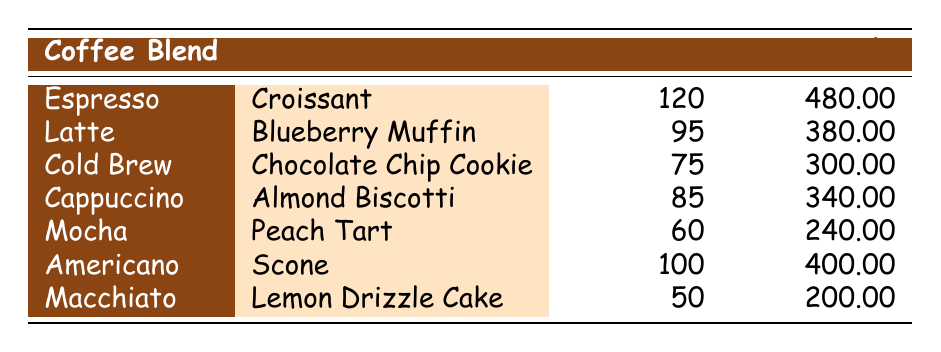What was the best-selling coffee blend in October 2023? The best-selling coffee blend can be found by looking at the "Units Sold" column. Among all the coffee blends, Espresso has the highest units sold at 120.
Answer: Espresso Which pastry was paired with the Mocha coffee blend? The table indicates the pairing for each coffee blend; for Mocha, the paired pastry is Peach Tart.
Answer: Peach Tart How much revenue did the Americano generate in October 2023? The revenue for the Americano coffee blend can be found directly in the "Revenue" column. For Americano, the revenue is $400.00.
Answer: 400.00 What was the total revenue generated from all coffee blends in October 2023? To find the total revenue, I will sum the revenue values for each coffee blend: 480 + 380 + 300 + 340 + 240 + 400 + 200 = 2320.00.
Answer: 2320.00 Did the Cappuccino sell more units than the Cold Brew? Looking at the "Units Sold" column, Cappuccino has 85 units sold while Cold Brew has 75 units sold. Thus, Cappuccino sold more units.
Answer: Yes What is the average number of units sold across all coffee blends? I will calculate this by summing the units sold: 120 + 95 + 75 + 85 + 60 + 100 + 50 = 685, and dividing by the total number of coffee blends, which is 7. So the average is 685 / 7 = 97.86.
Answer: 97.86 Which pastry pairing generated the least revenue? By examining the revenue amounts, I see that Macchiato with Lemon Drizzle Cake generated the least revenue at $200.00.
Answer: Lemon Drizzle Cake Did any coffee blend sell fewer than 70 units? Checking the "Units Sold" column, only the Macchiato sold 50 units, which is fewer than 70.
Answer: Yes How many coffee blends had a revenue of more than $300? By checking the "Revenue" column, I find that Espresso ($480), Latte ($380), Americano ($400), and Cappuccino ($340) all had revenues greater than $300. That's four coffee blends in total.
Answer: 4 